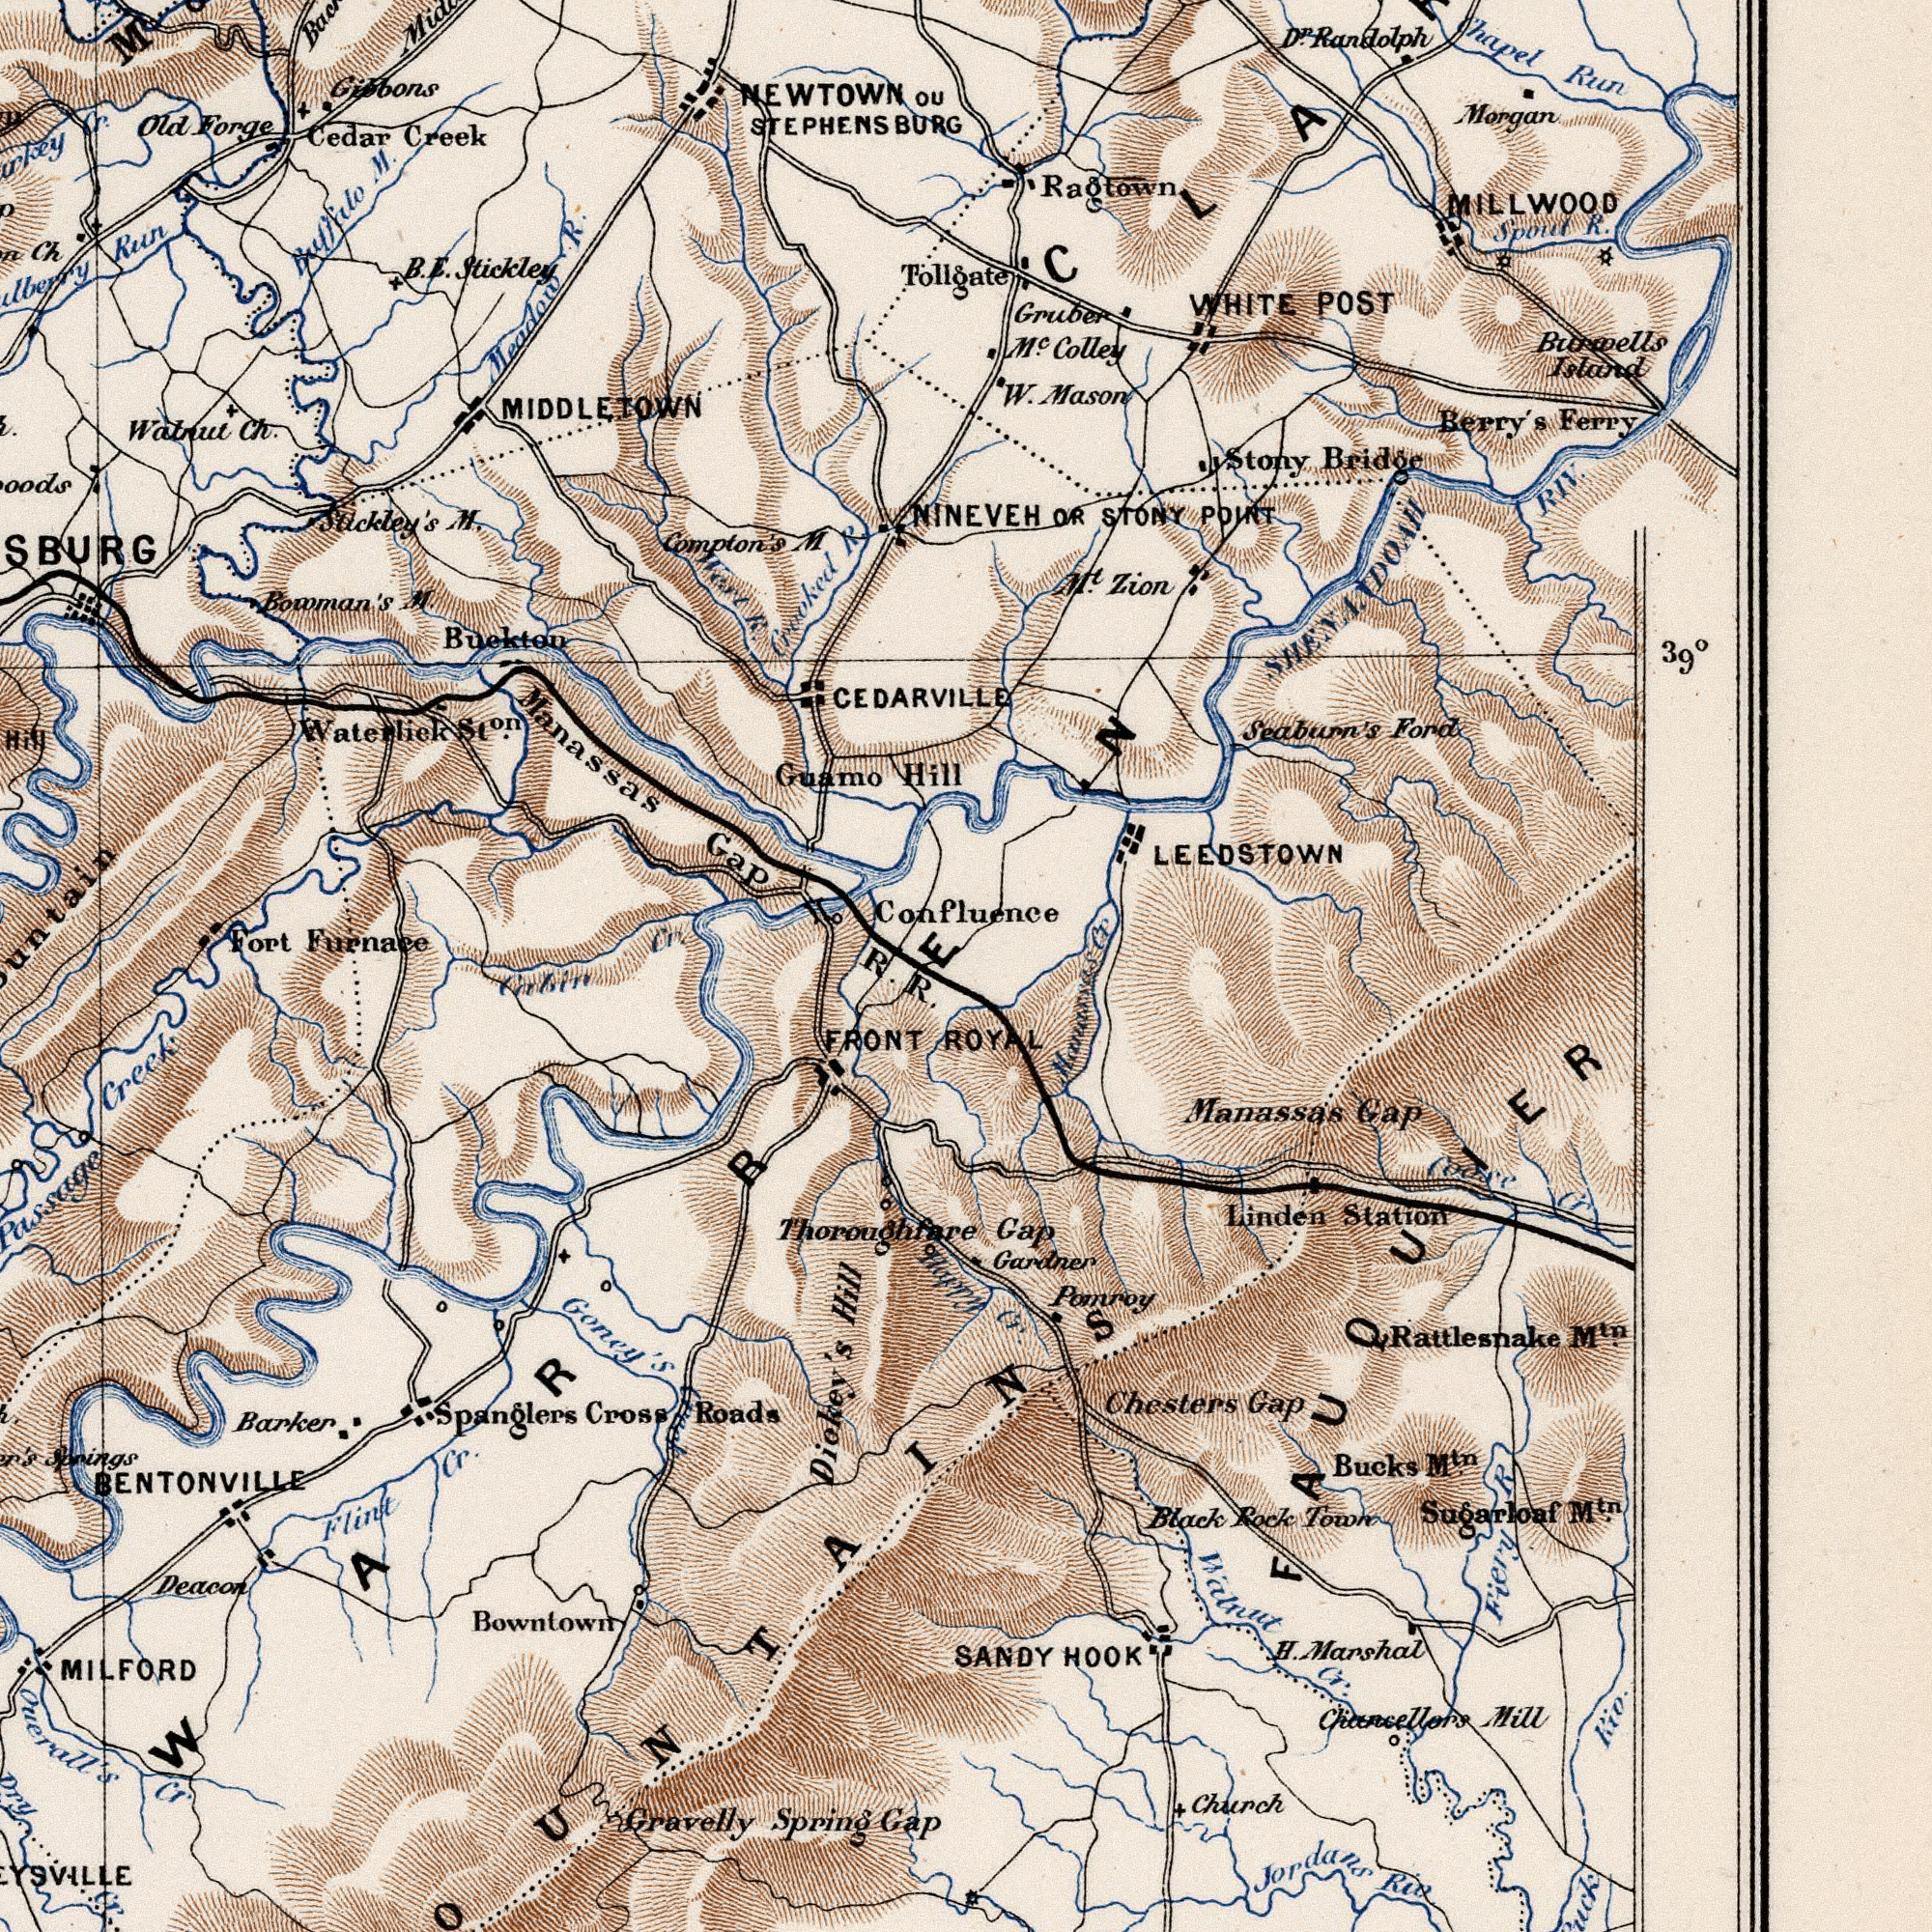What text can you see in the top-right section? Hill R. Tollgate CEDARVILLE Confluence STEPHENSBURG ou LEEDSTOWN WHITE POST Spout R. Chapel Run M<sup>t</sup>. Zion Burwells Island Colley Berry's Ferry MILLWOOD NINEVEH OR STONY POINT Morgan Stony Bridge W. Mason SHENANDOAH RIV. Ragtown Gruber Seaburn's Ford D<sup>r</sup>. Randolph 39Â° Cr What text is shown in the top-left quadrant? Guamo Fort Furnace Compton's M. Bowman's M. Meadow R. Stickley's M. Run Old Forge Manassas Gap Buckton B. E. Stickley Watnut Ch. Cedar Creek Crooked R. Buffilo M. Waterliek St<sup>on</sup>. Cr. Ch West R. Gibbons NEWTOWN MIDDLETOWN M Cr. What text is visible in the lower-right corner? R. Manassas Gap FRONT ROYAL Thoroughfare Gap Happy Cr. Sugarloaf M<sup>tn</sup>. Rattlesnake M<sup>tn</sup>. Chesters Gap Linden Station Gardner H. Marshal Church Manassas Gap Bucks M<sup>tn</sup>. Jordans Riv. Coose Cr Black Rock Town Chancellors Mill SANDY HOOK Wilnut Cr. Poinroy Fiery R Riv. FAUQUIER What text appears in the bottom-left area of the image? Cabin Gravelly Spring Spanglers Cross Roads MILFORD Goney's Creek Bowntown Ouerall's Cr Passage Creek Barker Flint Cr. Dickey’s Hill BENTONVILLE Dry Cr. Springs Deacon ###WARREN 